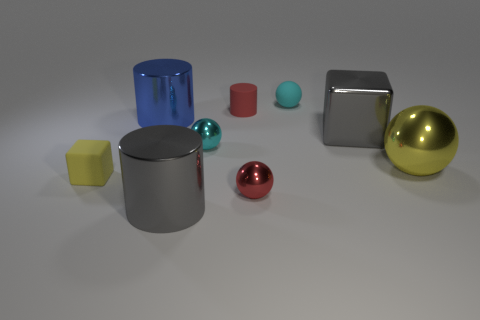Can you describe the lighting and shadows observed in the image? The illumination in the image comes from above, casting soft shadows directly underneath each object. The light seems diffused, as there are no harsh shadows, suggesting an evenly lit environment, likely with multiple light sources or a well-lit studio. 